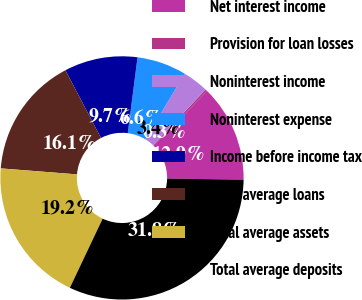<chart> <loc_0><loc_0><loc_500><loc_500><pie_chart><fcel>Net interest income<fcel>Provision for loan losses<fcel>Noninterest income<fcel>Noninterest expense<fcel>Income before income tax<fcel>Total average loans<fcel>Total average assets<fcel>Total average deposits<nl><fcel>12.89%<fcel>0.28%<fcel>3.43%<fcel>6.59%<fcel>9.74%<fcel>16.05%<fcel>19.2%<fcel>31.81%<nl></chart> 